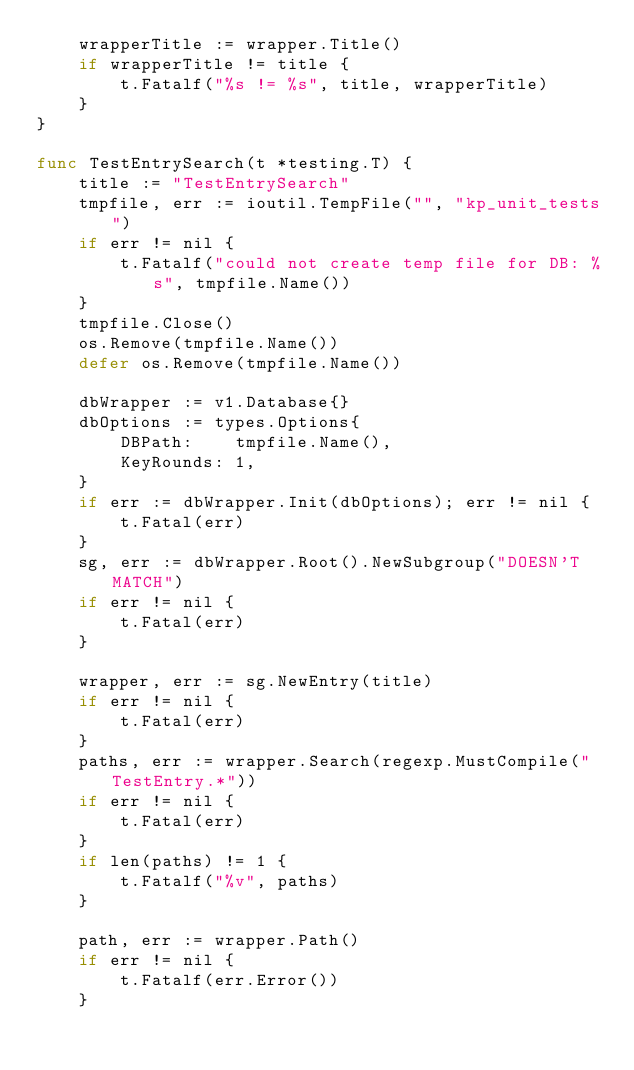Convert code to text. <code><loc_0><loc_0><loc_500><loc_500><_Go_>	wrapperTitle := wrapper.Title()
	if wrapperTitle != title {
		t.Fatalf("%s != %s", title, wrapperTitle)
	}
}

func TestEntrySearch(t *testing.T) {
	title := "TestEntrySearch"
	tmpfile, err := ioutil.TempFile("", "kp_unit_tests")
	if err != nil {
		t.Fatalf("could not create temp file for DB: %s", tmpfile.Name())
	}
	tmpfile.Close()
	os.Remove(tmpfile.Name())
	defer os.Remove(tmpfile.Name())

	dbWrapper := v1.Database{}
	dbOptions := types.Options{
		DBPath:    tmpfile.Name(),
		KeyRounds: 1,
	}
	if err := dbWrapper.Init(dbOptions); err != nil {
		t.Fatal(err)
	}
	sg, err := dbWrapper.Root().NewSubgroup("DOESN'T MATCH")
	if err != nil {
		t.Fatal(err)
	}

	wrapper, err := sg.NewEntry(title)
	if err != nil {
		t.Fatal(err)
	}
	paths, err := wrapper.Search(regexp.MustCompile("TestEntry.*"))
	if err != nil {
		t.Fatal(err)
	}
	if len(paths) != 1 {
		t.Fatalf("%v", paths)
	}

	path, err := wrapper.Path()
	if err != nil {
		t.Fatalf(err.Error())
	}</code> 